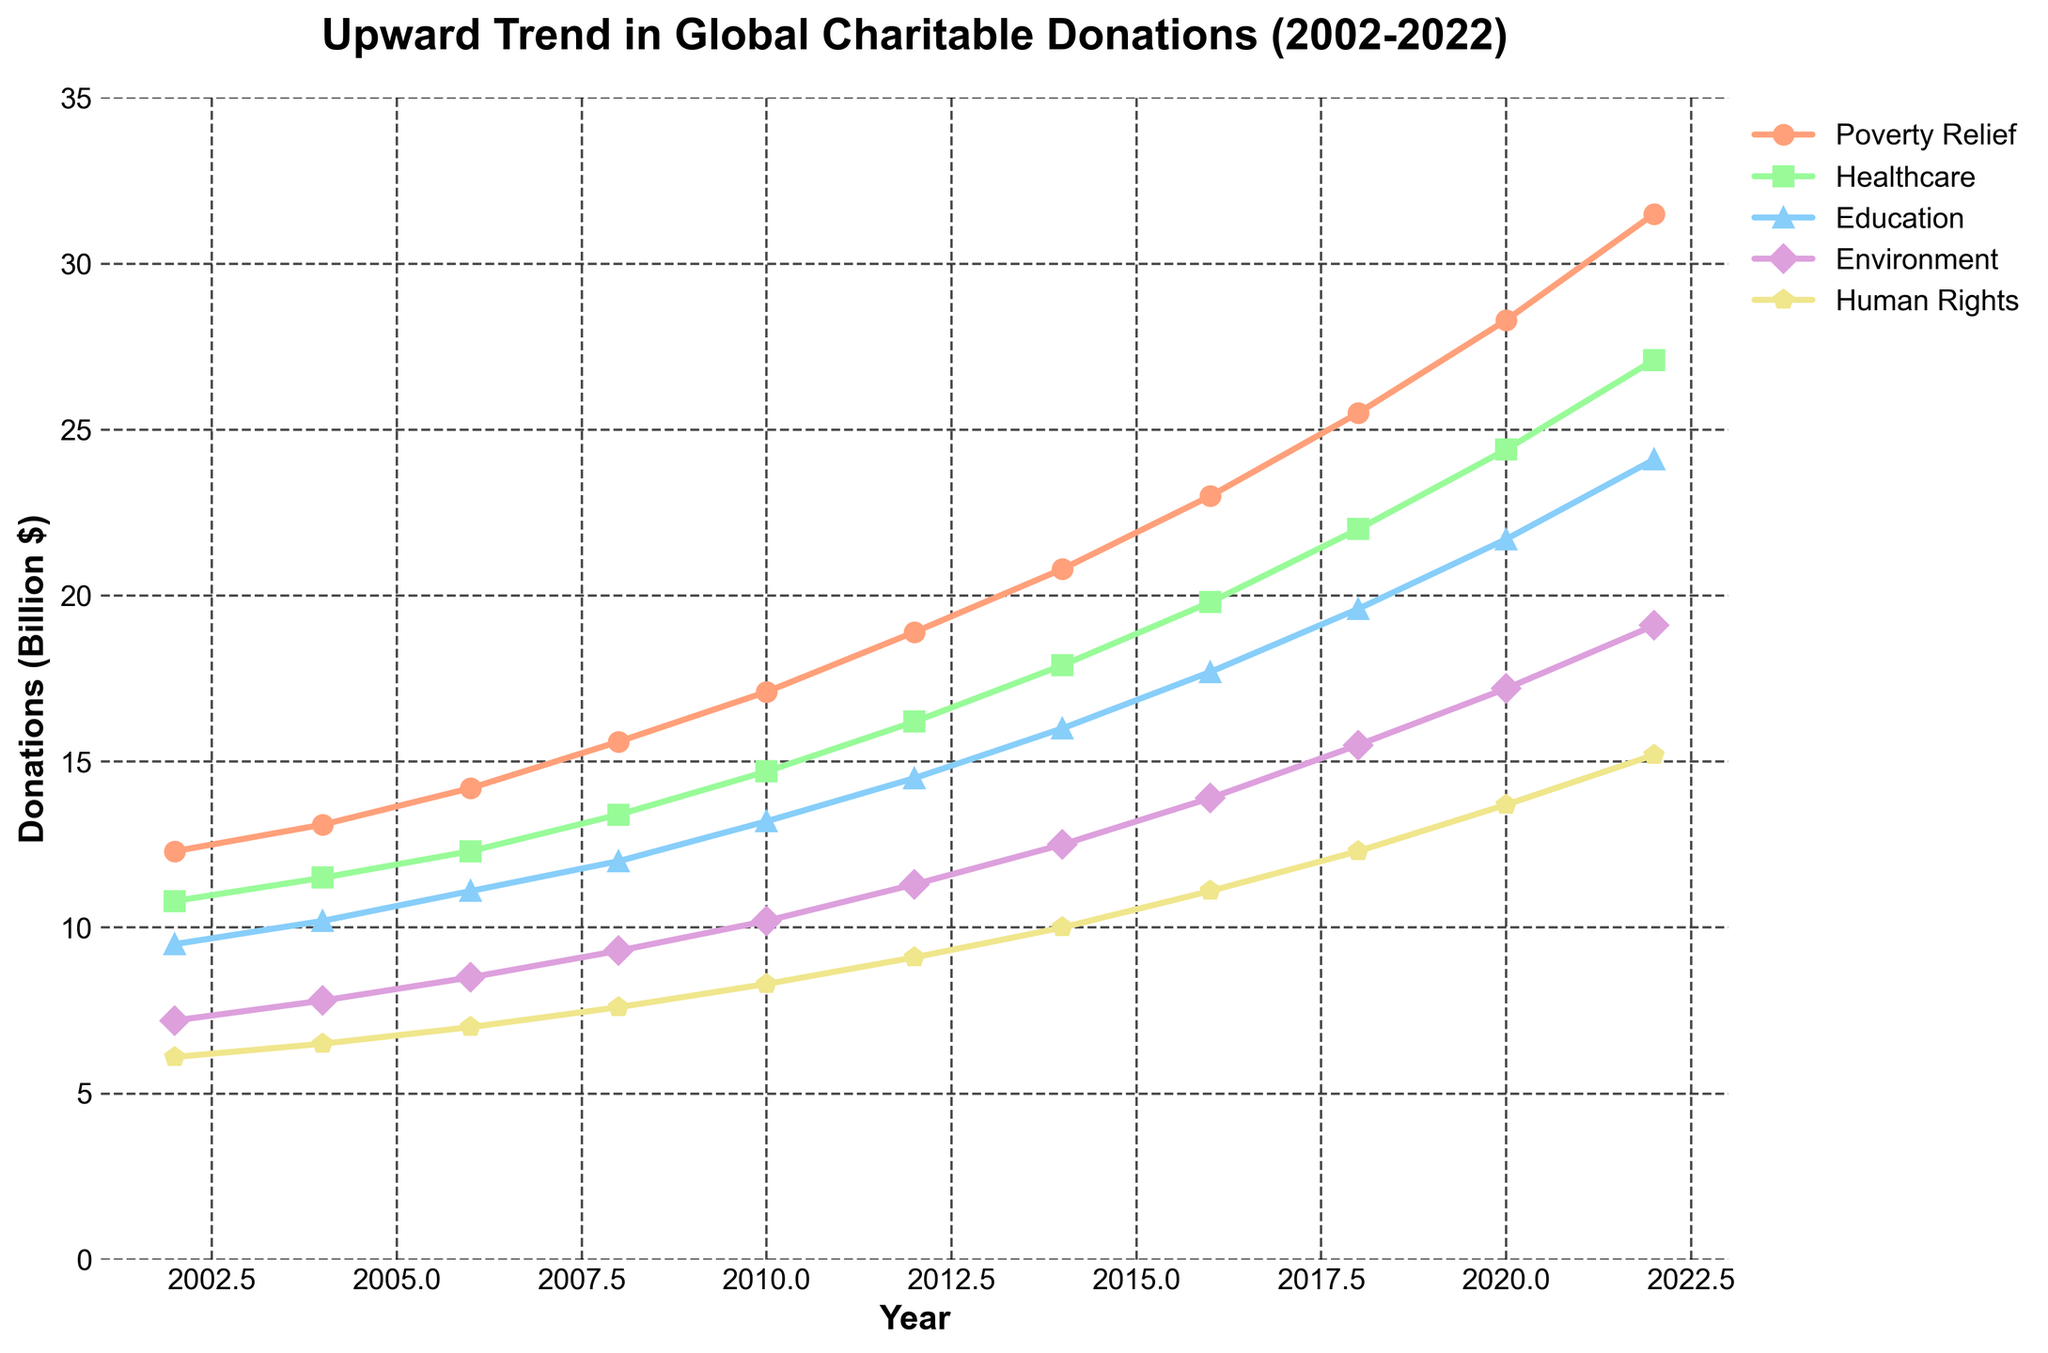Which cause category saw the highest increase in donations between 2002 and 2022? To determine the highest increase, we need to compare the donations in each category between 2002 and 2022. The difference for each is: Poverty Relief (31.5 - 12.3 = 19.2), Healthcare (27.1 - 10.8 = 16.3), Education (24.1 - 9.5 = 14.6), Environment (19.1 - 7.2 = 11.9), Human Rights (15.2 - 6.1 = 9.1). Thus, the highest increase is in the Poverty Relief category
Answer: Poverty Relief What was the total of charitable donations across all categories in 2012? Add the amounts of donations for each category in 2012: 18.9 (Poverty Relief) + 16.2 (Healthcare) + 14.5 (Education) + 11.3 (Environment) + 9.1 (Human Rights) = 70.0
Answer: 70.0 Which year had the lowest donation for the Environment cause, and what was the value? By observing the line for the Environment category, the year 2002 shows the lowest donation at 7.2 billion dollars
Answer: 2002, 7.2 Between Healthcare and Education, which category had the faster growth rate from 2002 to 2022? First, find the growth for both categories: Healthcare (27.1 - 10.8 = 16.3) and Education (24.1 - 9.5 = 14.6). Though both saw significant increases, Healthcare had a higher absolute growth (16.3 vs. 14.6)
Answer: Healthcare What is the average annual donation for the Human Rights cause over the 20 years? Add the donations from 2002 to 2022 and divide by the number of years (11): (6.1 + 6.5 + 7.0 + 7.6 + 8.3 + 9.1 + 10.0 + 11.1 + 12.3 + 13.7 + 15.2) / 11 = 9.18
Answer: 9.18 In which year did the Education category surpass 15 billion dollars in donations? Track the donations of Education over the years and note the first year it exceeds 15 billion: In 2014, donations were 16.0 billion dollars
Answer: 2014 Which category had the most consistent growth in donations over the years? By observing the slopes of the lines visually, the Poverty Relief category shows a relatively steady, consistent upward trend without significant fluctuations or drops
Answer: Poverty Relief What was the combined total of donations for Healthcare and Environment in 2020? Add the donations for Healthcare (24.4) and Environment (17.2) for the year 2020: 24.4 + 17.2 = 41.6
Answer: 41.6 Which cause had a more significant percentage increase from 2010 to 2018, Human Rights or Environment? Calculate the percentage increase for both: Human Rights (12.3 - 8.3) / 8.3 = 48.19%, Environment (15.5 - 10.2) / 10.2 = 52.23%. Thus, Environment had a higher percentage increase
Answer: Environment Was any category showing a decreasing trend at any point from 2002 to 2022? Explore the trajectories of all the lines across the entire timeline and confirm that none of the lines (categories) show a decline at any point, indicating all categories had an upward trend
Answer: No 